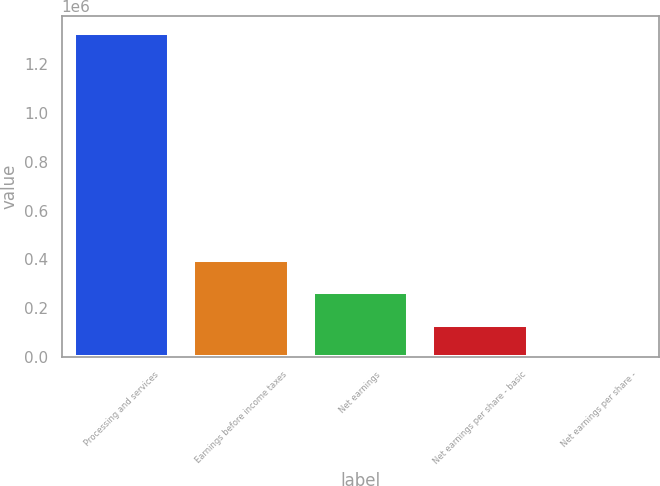<chart> <loc_0><loc_0><loc_500><loc_500><bar_chart><fcel>Processing and services<fcel>Earnings before income taxes<fcel>Net earnings<fcel>Net earnings per share - basic<fcel>Net earnings per share -<nl><fcel>1.33041e+06<fcel>399125<fcel>266083<fcel>133042<fcel>0.55<nl></chart> 